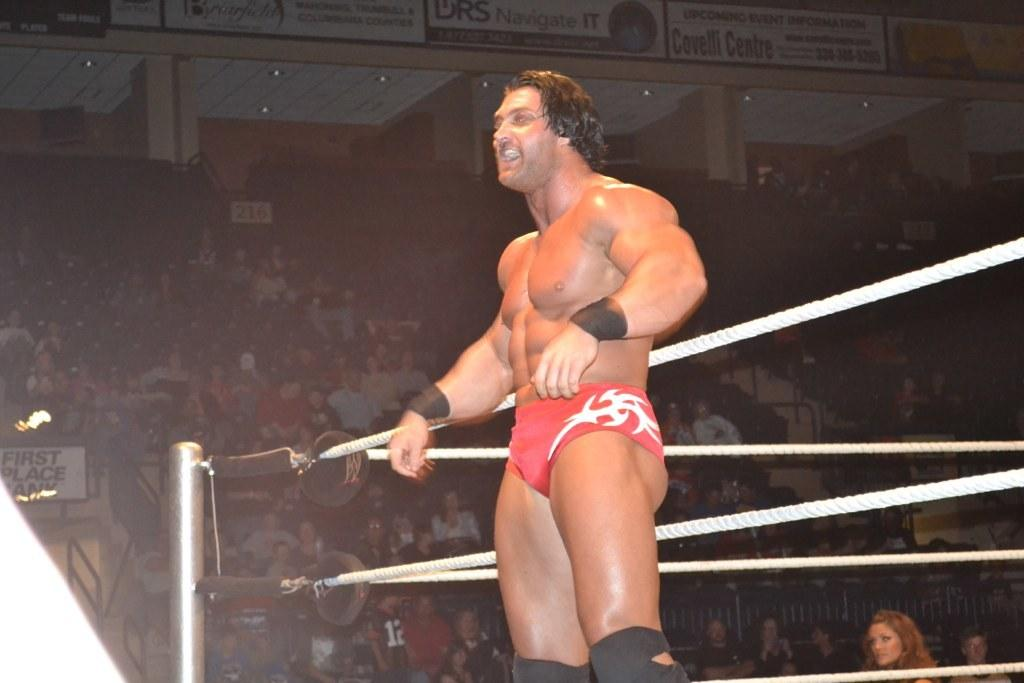<image>
Share a concise interpretation of the image provided. The word navigate is shown on the sign above the wrestler's head. 